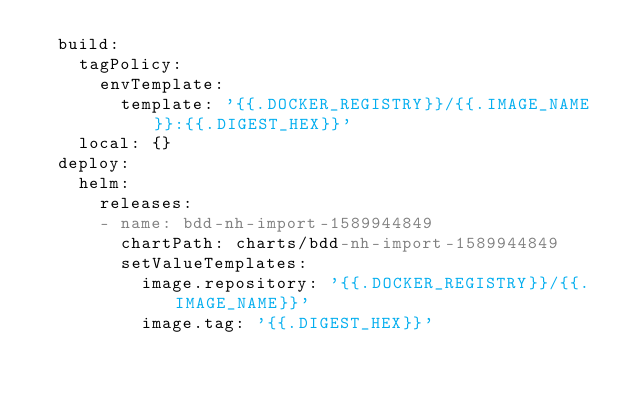Convert code to text. <code><loc_0><loc_0><loc_500><loc_500><_YAML_>  build:
    tagPolicy:
      envTemplate:
        template: '{{.DOCKER_REGISTRY}}/{{.IMAGE_NAME}}:{{.DIGEST_HEX}}'
    local: {}
  deploy:
    helm:
      releases:
      - name: bdd-nh-import-1589944849
        chartPath: charts/bdd-nh-import-1589944849
        setValueTemplates:
          image.repository: '{{.DOCKER_REGISTRY}}/{{.IMAGE_NAME}}'
          image.tag: '{{.DIGEST_HEX}}'
</code> 